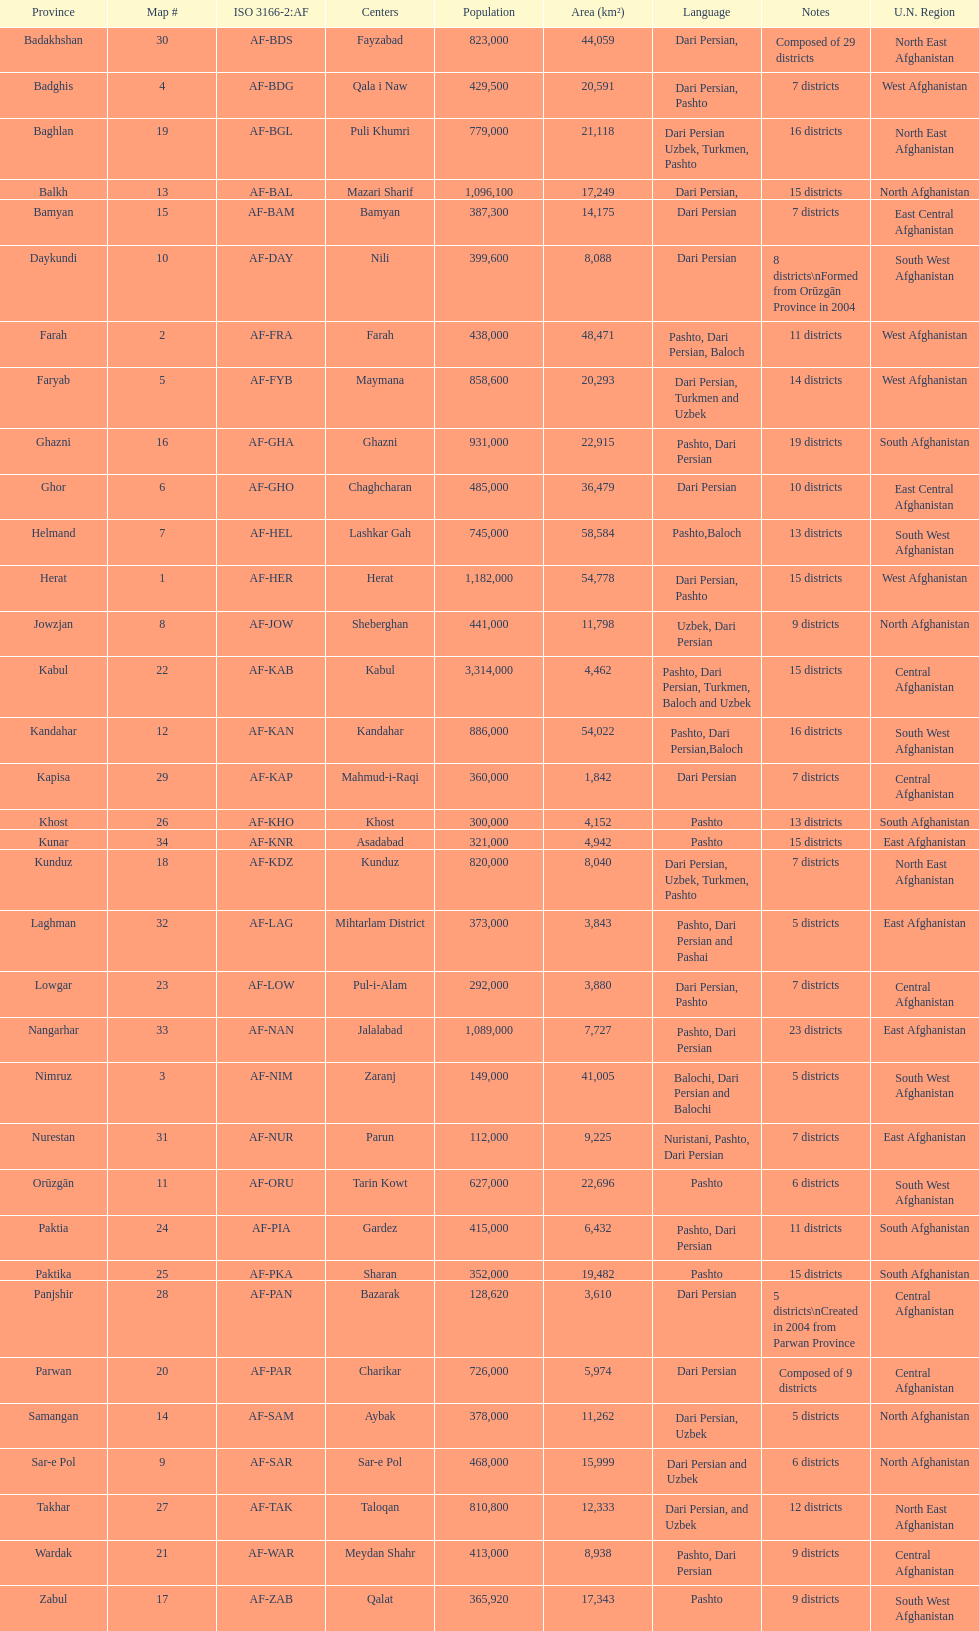In which province does the largest quantity of districts exist? Badakhshan. I'm looking to parse the entire table for insights. Could you assist me with that? {'header': ['Province', 'Map #', 'ISO 3166-2:AF', 'Centers', 'Population', 'Area (km²)', 'Language', 'Notes', 'U.N. Region'], 'rows': [['Badakhshan', '30', 'AF-BDS', 'Fayzabad', '823,000', '44,059', 'Dari Persian,', 'Composed of 29 districts', 'North East Afghanistan'], ['Badghis', '4', 'AF-BDG', 'Qala i Naw', '429,500', '20,591', 'Dari Persian, Pashto', '7 districts', 'West Afghanistan'], ['Baghlan', '19', 'AF-BGL', 'Puli Khumri', '779,000', '21,118', 'Dari Persian Uzbek, Turkmen, Pashto', '16 districts', 'North East Afghanistan'], ['Balkh', '13', 'AF-BAL', 'Mazari Sharif', '1,096,100', '17,249', 'Dari Persian,', '15 districts', 'North Afghanistan'], ['Bamyan', '15', 'AF-BAM', 'Bamyan', '387,300', '14,175', 'Dari Persian', '7 districts', 'East Central Afghanistan'], ['Daykundi', '10', 'AF-DAY', 'Nili', '399,600', '8,088', 'Dari Persian', '8 districts\\nFormed from Orūzgān Province in 2004', 'South West Afghanistan'], ['Farah', '2', 'AF-FRA', 'Farah', '438,000', '48,471', 'Pashto, Dari Persian, Baloch', '11 districts', 'West Afghanistan'], ['Faryab', '5', 'AF-FYB', 'Maymana', '858,600', '20,293', 'Dari Persian, Turkmen and Uzbek', '14 districts', 'West Afghanistan'], ['Ghazni', '16', 'AF-GHA', 'Ghazni', '931,000', '22,915', 'Pashto, Dari Persian', '19 districts', 'South Afghanistan'], ['Ghor', '6', 'AF-GHO', 'Chaghcharan', '485,000', '36,479', 'Dari Persian', '10 districts', 'East Central Afghanistan'], ['Helmand', '7', 'AF-HEL', 'Lashkar Gah', '745,000', '58,584', 'Pashto,Baloch', '13 districts', 'South West Afghanistan'], ['Herat', '1', 'AF-HER', 'Herat', '1,182,000', '54,778', 'Dari Persian, Pashto', '15 districts', 'West Afghanistan'], ['Jowzjan', '8', 'AF-JOW', 'Sheberghan', '441,000', '11,798', 'Uzbek, Dari Persian', '9 districts', 'North Afghanistan'], ['Kabul', '22', 'AF-KAB', 'Kabul', '3,314,000', '4,462', 'Pashto, Dari Persian, Turkmen, Baloch and Uzbek', '15 districts', 'Central Afghanistan'], ['Kandahar', '12', 'AF-KAN', 'Kandahar', '886,000', '54,022', 'Pashto, Dari Persian,Baloch', '16 districts', 'South West Afghanistan'], ['Kapisa', '29', 'AF-KAP', 'Mahmud-i-Raqi', '360,000', '1,842', 'Dari Persian', '7 districts', 'Central Afghanistan'], ['Khost', '26', 'AF-KHO', 'Khost', '300,000', '4,152', 'Pashto', '13 districts', 'South Afghanistan'], ['Kunar', '34', 'AF-KNR', 'Asadabad', '321,000', '4,942', 'Pashto', '15 districts', 'East Afghanistan'], ['Kunduz', '18', 'AF-KDZ', 'Kunduz', '820,000', '8,040', 'Dari Persian, Uzbek, Turkmen, Pashto', '7 districts', 'North East Afghanistan'], ['Laghman', '32', 'AF-LAG', 'Mihtarlam District', '373,000', '3,843', 'Pashto, Dari Persian and Pashai', '5 districts', 'East Afghanistan'], ['Lowgar', '23', 'AF-LOW', 'Pul-i-Alam', '292,000', '3,880', 'Dari Persian, Pashto', '7 districts', 'Central Afghanistan'], ['Nangarhar', '33', 'AF-NAN', 'Jalalabad', '1,089,000', '7,727', 'Pashto, Dari Persian', '23 districts', 'East Afghanistan'], ['Nimruz', '3', 'AF-NIM', 'Zaranj', '149,000', '41,005', 'Balochi, Dari Persian and Balochi', '5 districts', 'South West Afghanistan'], ['Nurestan', '31', 'AF-NUR', 'Parun', '112,000', '9,225', 'Nuristani, Pashto, Dari Persian', '7 districts', 'East Afghanistan'], ['Orūzgān', '11', 'AF-ORU', 'Tarin Kowt', '627,000', '22,696', 'Pashto', '6 districts', 'South West Afghanistan'], ['Paktia', '24', 'AF-PIA', 'Gardez', '415,000', '6,432', 'Pashto, Dari Persian', '11 districts', 'South Afghanistan'], ['Paktika', '25', 'AF-PKA', 'Sharan', '352,000', '19,482', 'Pashto', '15 districts', 'South Afghanistan'], ['Panjshir', '28', 'AF-PAN', 'Bazarak', '128,620', '3,610', 'Dari Persian', '5 districts\\nCreated in 2004 from Parwan Province', 'Central Afghanistan'], ['Parwan', '20', 'AF-PAR', 'Charikar', '726,000', '5,974', 'Dari Persian', 'Composed of 9 districts', 'Central Afghanistan'], ['Samangan', '14', 'AF-SAM', 'Aybak', '378,000', '11,262', 'Dari Persian, Uzbek', '5 districts', 'North Afghanistan'], ['Sar-e Pol', '9', 'AF-SAR', 'Sar-e Pol', '468,000', '15,999', 'Dari Persian and Uzbek', '6 districts', 'North Afghanistan'], ['Takhar', '27', 'AF-TAK', 'Taloqan', '810,800', '12,333', 'Dari Persian, and Uzbek', '12 districts', 'North East Afghanistan'], ['Wardak', '21', 'AF-WAR', 'Meydan Shahr', '413,000', '8,938', 'Pashto, Dari Persian', '9 districts', 'Central Afghanistan'], ['Zabul', '17', 'AF-ZAB', 'Qalat', '365,920', '17,343', 'Pashto', '9 districts', 'South West Afghanistan']]} 